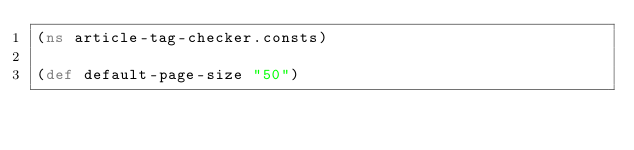<code> <loc_0><loc_0><loc_500><loc_500><_Clojure_>(ns article-tag-checker.consts)

(def default-page-size "50")</code> 